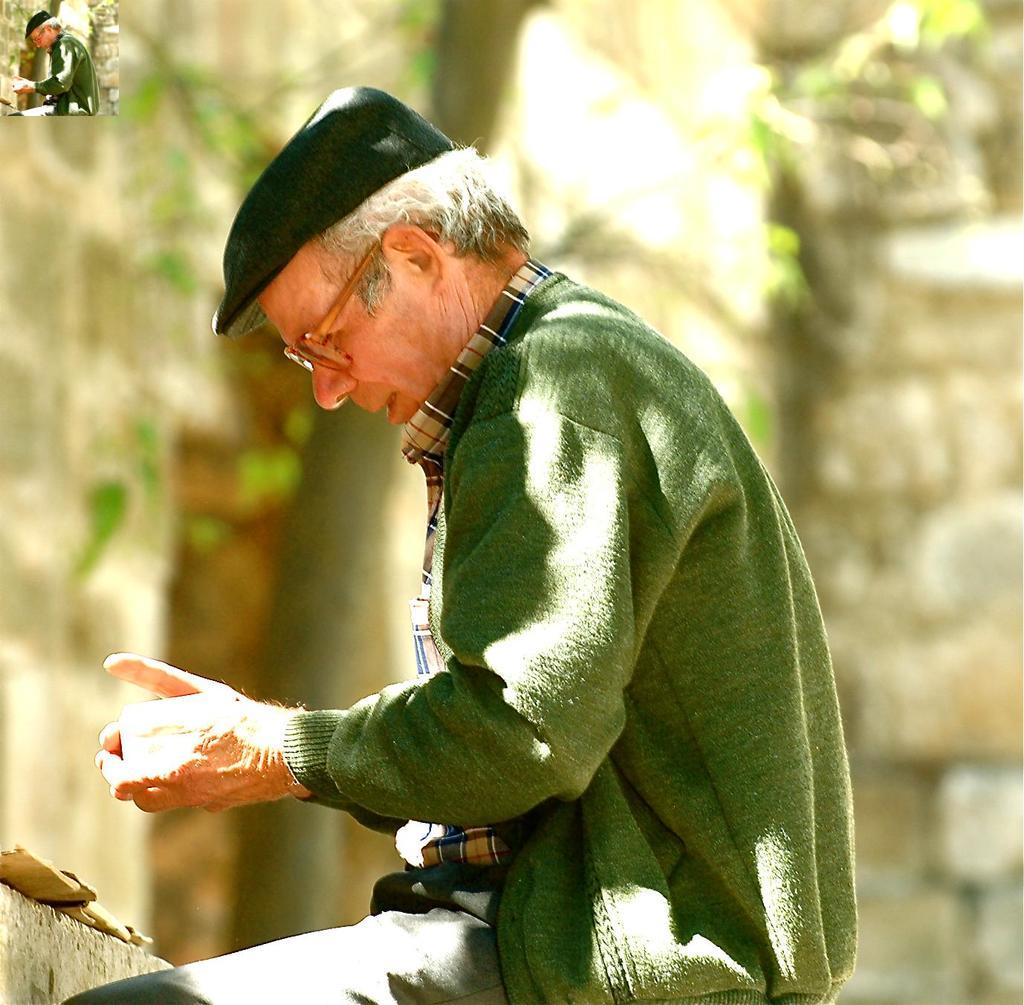What is the man in the image doing? The man is sitting in the image. Is there anything else related to the man in the image? Yes, there is a miniature image of the man on the left side. What type of natural element can be seen in the image? There is a tree visible in the image. What type of structure is visible in the image? There is a wall visible in the image. What type of brass instrument is the man playing in the image? There is no brass instrument present in the image; the man is simply sitting. 